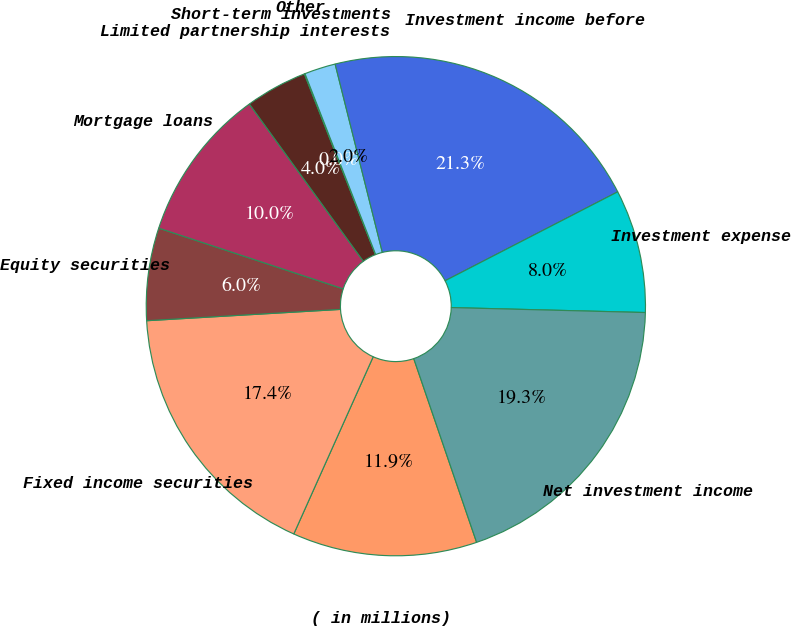<chart> <loc_0><loc_0><loc_500><loc_500><pie_chart><fcel>( in millions)<fcel>Fixed income securities<fcel>Equity securities<fcel>Mortgage loans<fcel>Limited partnership interests<fcel>Short-term investments<fcel>Other<fcel>Investment income before<fcel>Investment expense<fcel>Net investment income<nl><fcel>11.95%<fcel>17.37%<fcel>5.99%<fcel>9.96%<fcel>4.01%<fcel>0.04%<fcel>2.02%<fcel>21.34%<fcel>7.98%<fcel>19.35%<nl></chart> 